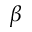Convert formula to latex. <formula><loc_0><loc_0><loc_500><loc_500>\beta</formula> 